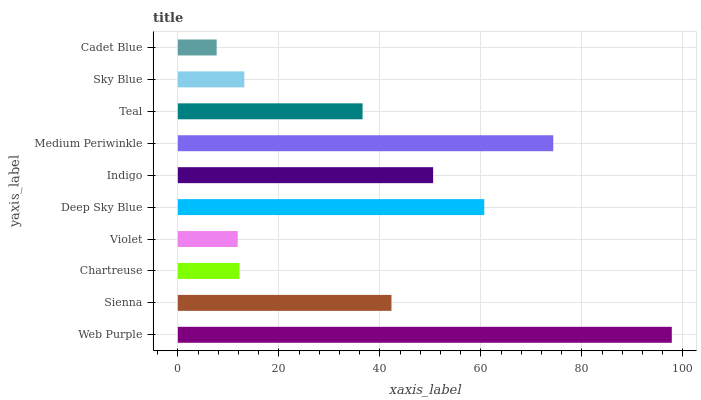Is Cadet Blue the minimum?
Answer yes or no. Yes. Is Web Purple the maximum?
Answer yes or no. Yes. Is Sienna the minimum?
Answer yes or no. No. Is Sienna the maximum?
Answer yes or no. No. Is Web Purple greater than Sienna?
Answer yes or no. Yes. Is Sienna less than Web Purple?
Answer yes or no. Yes. Is Sienna greater than Web Purple?
Answer yes or no. No. Is Web Purple less than Sienna?
Answer yes or no. No. Is Sienna the high median?
Answer yes or no. Yes. Is Teal the low median?
Answer yes or no. Yes. Is Chartreuse the high median?
Answer yes or no. No. Is Indigo the low median?
Answer yes or no. No. 